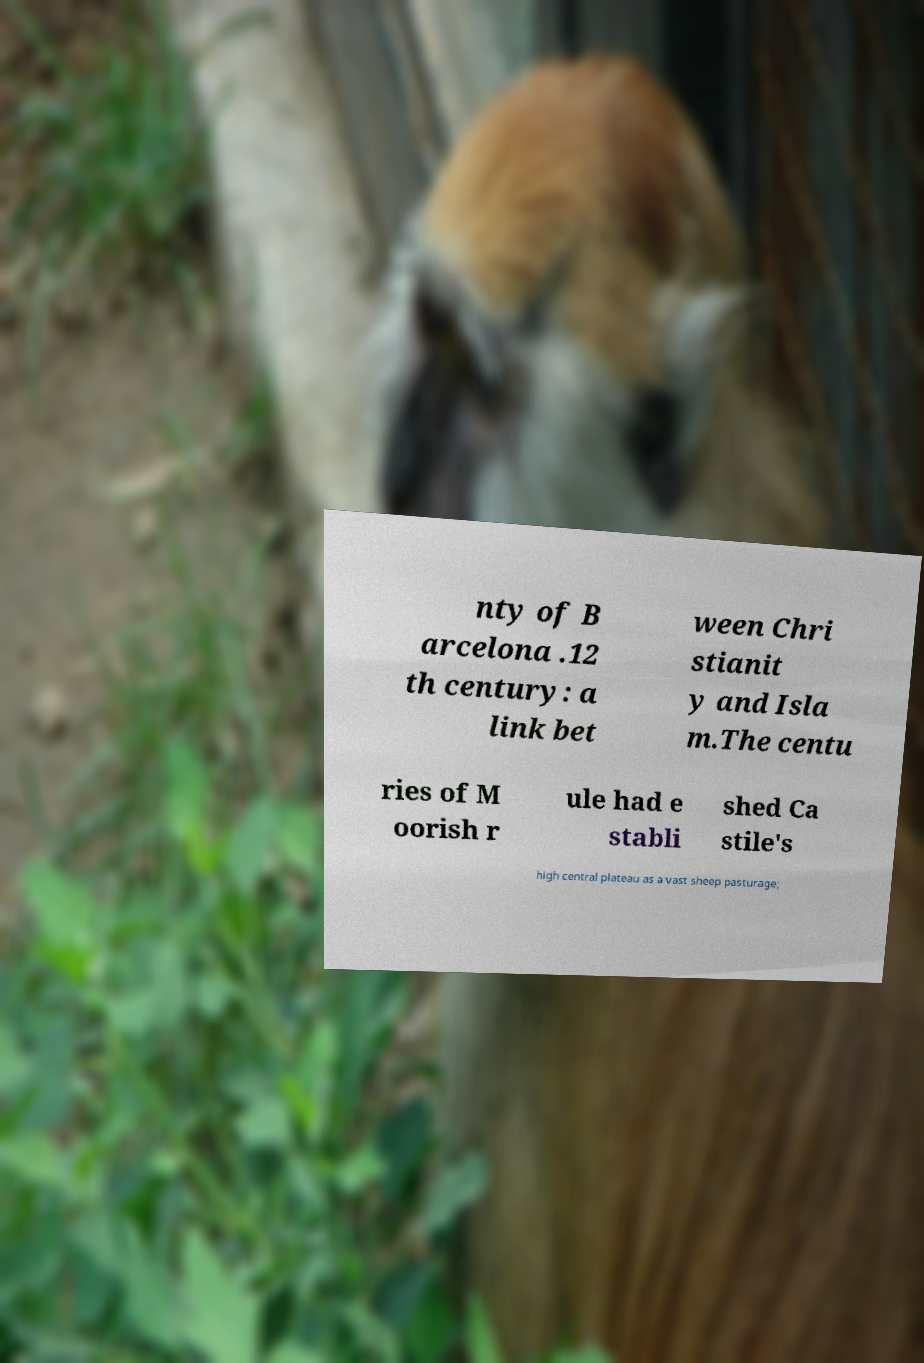What messages or text are displayed in this image? I need them in a readable, typed format. nty of B arcelona .12 th century: a link bet ween Chri stianit y and Isla m.The centu ries of M oorish r ule had e stabli shed Ca stile's high central plateau as a vast sheep pasturage; 